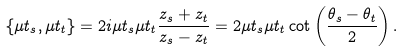Convert formula to latex. <formula><loc_0><loc_0><loc_500><loc_500>\{ \mu t _ { s } , \mu t _ { t } \} = 2 i \mu t _ { s } \mu t _ { t } \frac { z _ { s } + z _ { t } } { z _ { s } - z _ { t } } = 2 \mu t _ { s } \mu t _ { t } \cot \left ( \frac { \theta _ { s } - \theta _ { t } } { 2 } \right ) .</formula> 